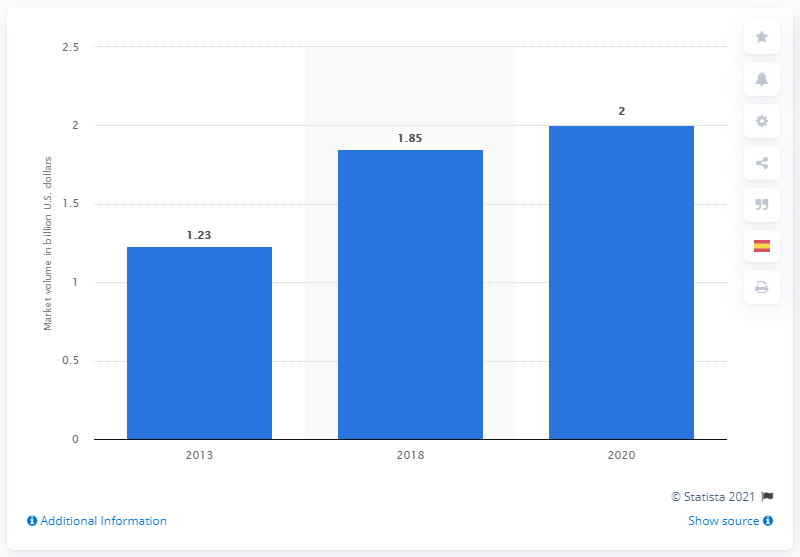Draw attention to some important aspects in this diagram. The global medical alert systems/PERS market volume was in 2013. In 2013, the global market size for medical alert systems/PERS was 1.23 billion. The market size for medical alert systems and PERS is expected to increase by 2020 to 1.23 billion. 